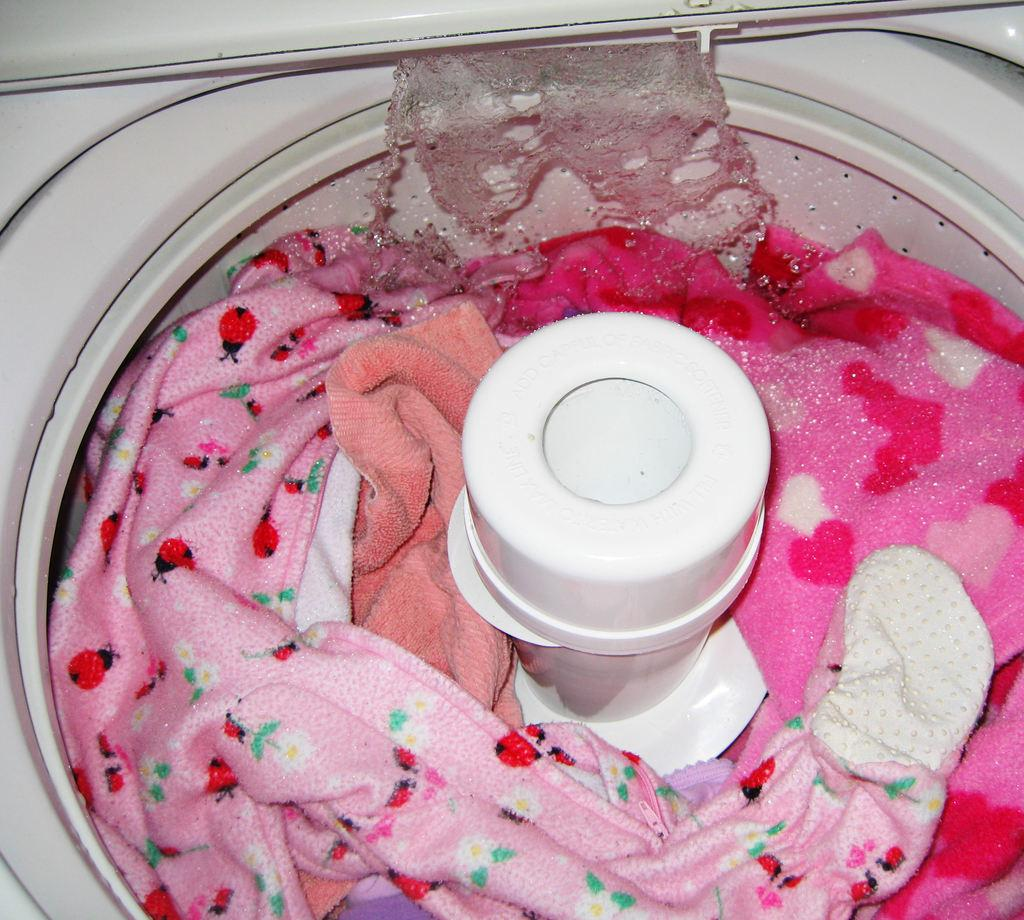What is inside the appliance that is visible in the image? There are clothes in the washing machine. What can be seen in the image besides the washing machine? There is water visible in the image. What type of lamp is illuminating the clothes in the washing machine? There is no lamp present in the image; the clothes are inside a washing machine with water visible. 